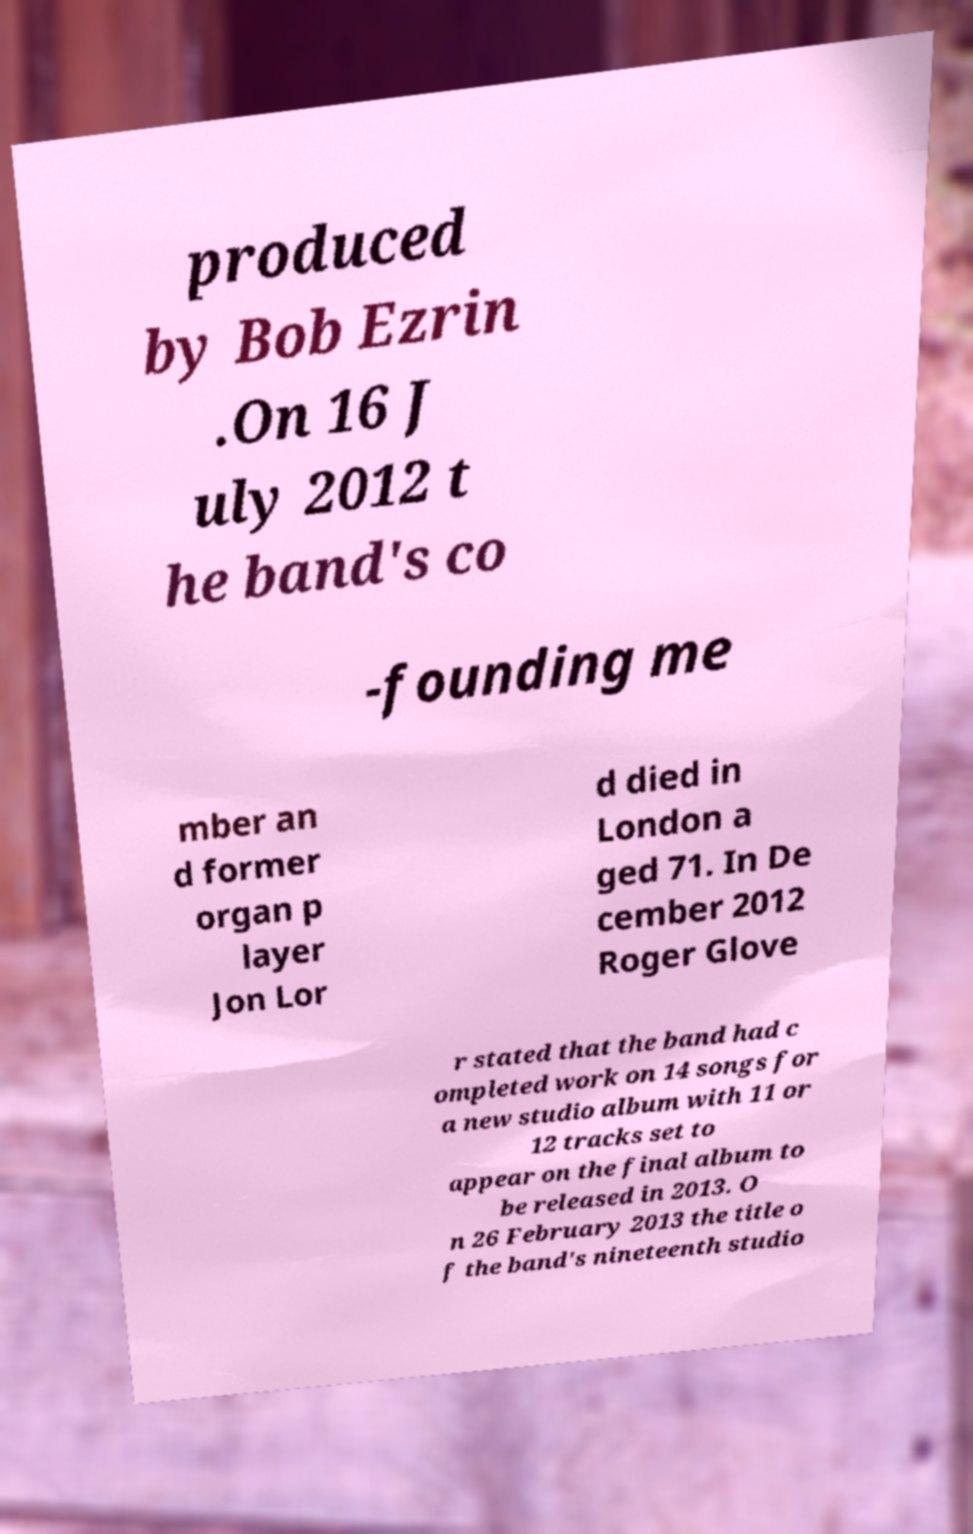Please identify and transcribe the text found in this image. produced by Bob Ezrin .On 16 J uly 2012 t he band's co -founding me mber an d former organ p layer Jon Lor d died in London a ged 71. In De cember 2012 Roger Glove r stated that the band had c ompleted work on 14 songs for a new studio album with 11 or 12 tracks set to appear on the final album to be released in 2013. O n 26 February 2013 the title o f the band's nineteenth studio 